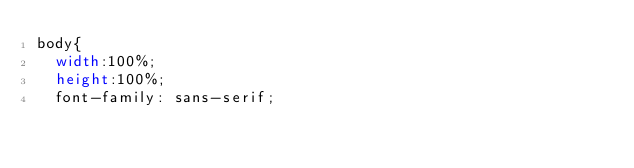<code> <loc_0><loc_0><loc_500><loc_500><_CSS_>body{
  width:100%;
  height:100%;
  font-family: sans-serif;</code> 